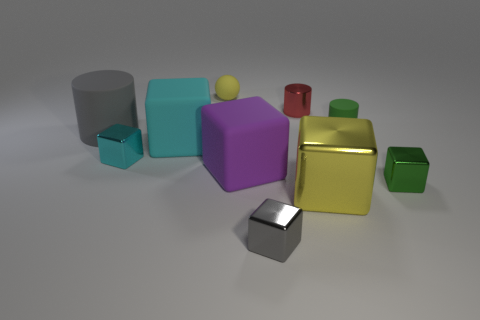Subtract all small gray cubes. How many cubes are left? 5 Subtract 3 cubes. How many cubes are left? 3 Subtract all green blocks. How many blocks are left? 5 Subtract all yellow cubes. Subtract all yellow cylinders. How many cubes are left? 5 Subtract all cylinders. How many objects are left? 7 Subtract all matte objects. Subtract all small blue shiny cubes. How many objects are left? 5 Add 5 yellow things. How many yellow things are left? 7 Add 3 green shiny blocks. How many green shiny blocks exist? 4 Subtract 0 gray spheres. How many objects are left? 10 